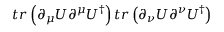Convert formula to latex. <formula><loc_0><loc_0><loc_500><loc_500>t r \left ( \partial _ { \mu } U \partial ^ { \mu } U ^ { \dagger } \right ) t r \left ( \partial _ { \nu } U \partial ^ { \nu } U ^ { \dagger } \right )</formula> 